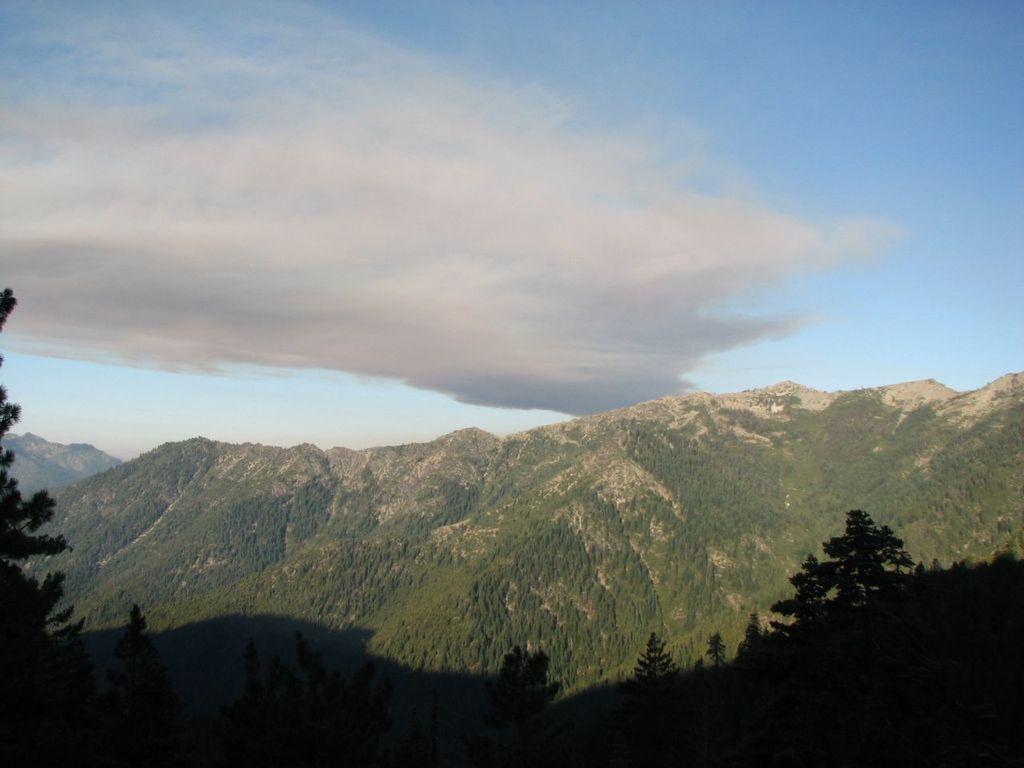How would you summarize this image in a sentence or two? In this image I can see hills. There are trees and in the background there is sky. 